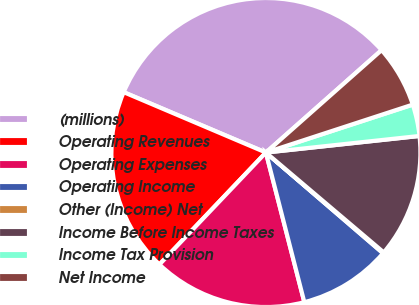<chart> <loc_0><loc_0><loc_500><loc_500><pie_chart><fcel>(millions)<fcel>Operating Revenues<fcel>Operating Expenses<fcel>Operating Income<fcel>Other (Income) Net<fcel>Income Before Income Taxes<fcel>Income Tax Provision<fcel>Net Income<nl><fcel>32.08%<fcel>19.29%<fcel>16.1%<fcel>9.7%<fcel>0.11%<fcel>12.9%<fcel>3.31%<fcel>6.51%<nl></chart> 